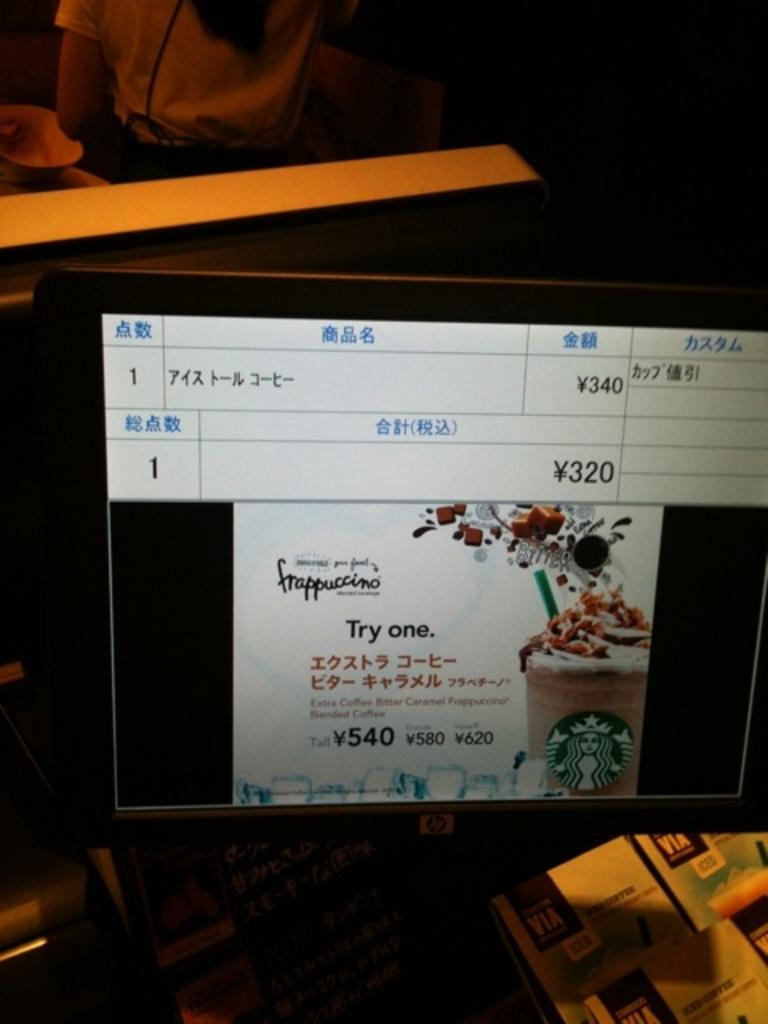<image>
Render a clear and concise summary of the photo. A monitor displays an advertisement for Starbucks Frappuccino. 